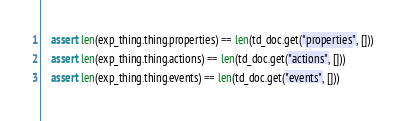<code> <loc_0><loc_0><loc_500><loc_500><_Python_>    assert len(exp_thing.thing.properties) == len(td_doc.get("properties", []))
    assert len(exp_thing.thing.actions) == len(td_doc.get("actions", []))
    assert len(exp_thing.thing.events) == len(td_doc.get("events", []))
</code> 